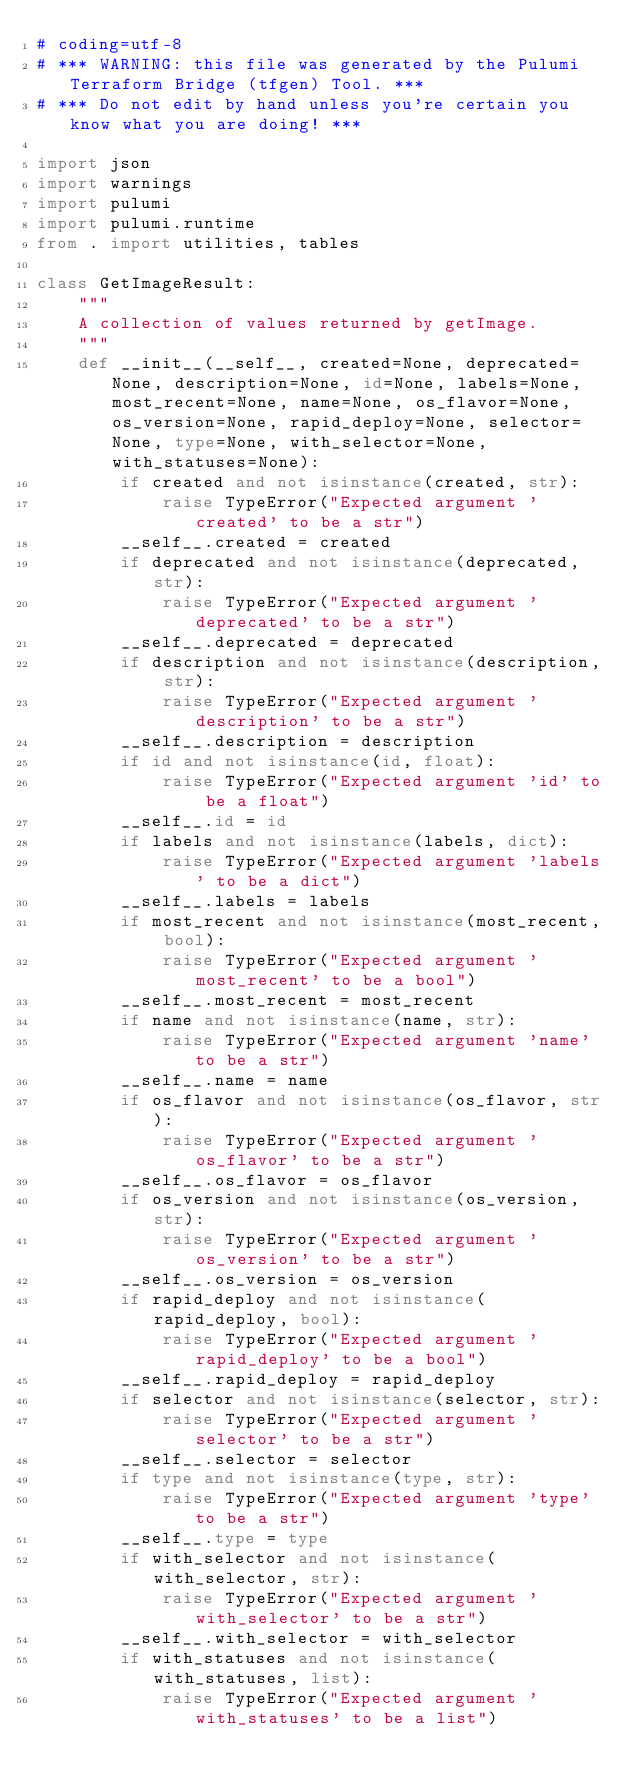<code> <loc_0><loc_0><loc_500><loc_500><_Python_># coding=utf-8
# *** WARNING: this file was generated by the Pulumi Terraform Bridge (tfgen) Tool. ***
# *** Do not edit by hand unless you're certain you know what you are doing! ***

import json
import warnings
import pulumi
import pulumi.runtime
from . import utilities, tables

class GetImageResult:
    """
    A collection of values returned by getImage.
    """
    def __init__(__self__, created=None, deprecated=None, description=None, id=None, labels=None, most_recent=None, name=None, os_flavor=None, os_version=None, rapid_deploy=None, selector=None, type=None, with_selector=None, with_statuses=None):
        if created and not isinstance(created, str):
            raise TypeError("Expected argument 'created' to be a str")
        __self__.created = created
        if deprecated and not isinstance(deprecated, str):
            raise TypeError("Expected argument 'deprecated' to be a str")
        __self__.deprecated = deprecated
        if description and not isinstance(description, str):
            raise TypeError("Expected argument 'description' to be a str")
        __self__.description = description
        if id and not isinstance(id, float):
            raise TypeError("Expected argument 'id' to be a float")
        __self__.id = id
        if labels and not isinstance(labels, dict):
            raise TypeError("Expected argument 'labels' to be a dict")
        __self__.labels = labels
        if most_recent and not isinstance(most_recent, bool):
            raise TypeError("Expected argument 'most_recent' to be a bool")
        __self__.most_recent = most_recent
        if name and not isinstance(name, str):
            raise TypeError("Expected argument 'name' to be a str")
        __self__.name = name
        if os_flavor and not isinstance(os_flavor, str):
            raise TypeError("Expected argument 'os_flavor' to be a str")
        __self__.os_flavor = os_flavor
        if os_version and not isinstance(os_version, str):
            raise TypeError("Expected argument 'os_version' to be a str")
        __self__.os_version = os_version
        if rapid_deploy and not isinstance(rapid_deploy, bool):
            raise TypeError("Expected argument 'rapid_deploy' to be a bool")
        __self__.rapid_deploy = rapid_deploy
        if selector and not isinstance(selector, str):
            raise TypeError("Expected argument 'selector' to be a str")
        __self__.selector = selector
        if type and not isinstance(type, str):
            raise TypeError("Expected argument 'type' to be a str")
        __self__.type = type
        if with_selector and not isinstance(with_selector, str):
            raise TypeError("Expected argument 'with_selector' to be a str")
        __self__.with_selector = with_selector
        if with_statuses and not isinstance(with_statuses, list):
            raise TypeError("Expected argument 'with_statuses' to be a list")</code> 